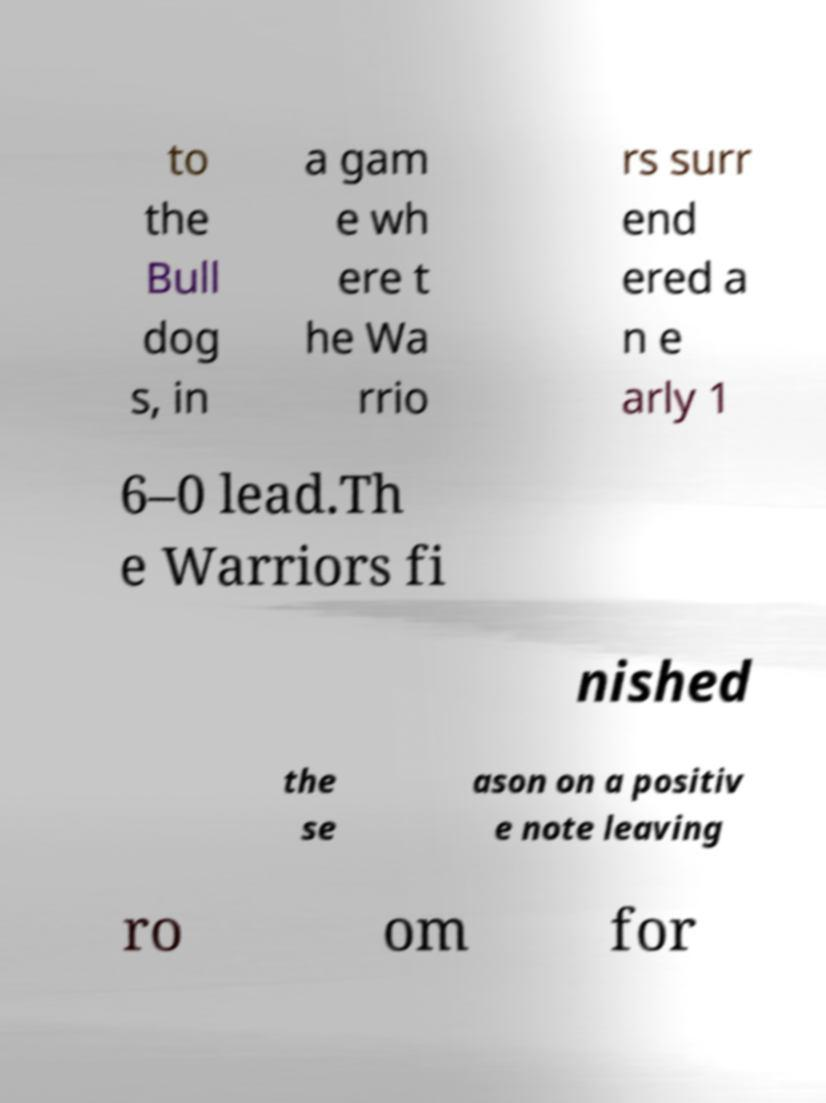Could you extract and type out the text from this image? to the Bull dog s, in a gam e wh ere t he Wa rrio rs surr end ered a n e arly 1 6–0 lead.Th e Warriors fi nished the se ason on a positiv e note leaving ro om for 